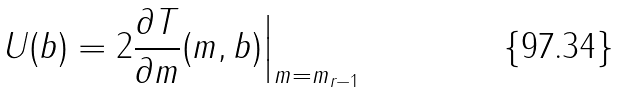Convert formula to latex. <formula><loc_0><loc_0><loc_500><loc_500>U ( b ) = 2 \frac { \partial T } { \partial m } ( m , b ) \Big | _ { m = m _ { r - 1 } }</formula> 